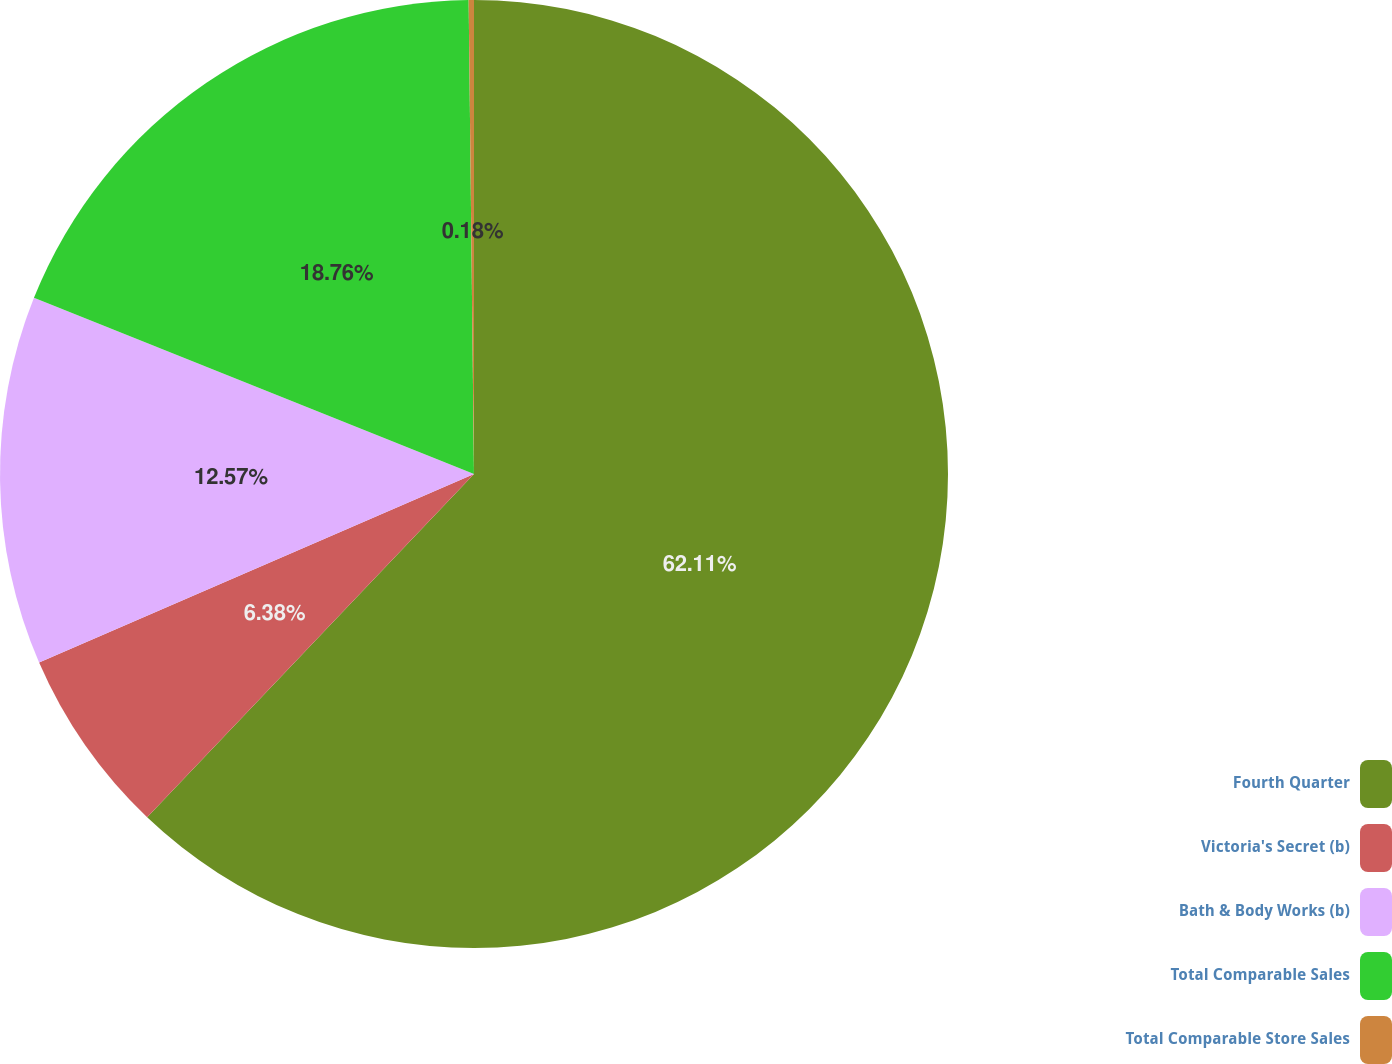Convert chart to OTSL. <chart><loc_0><loc_0><loc_500><loc_500><pie_chart><fcel>Fourth Quarter<fcel>Victoria's Secret (b)<fcel>Bath & Body Works (b)<fcel>Total Comparable Sales<fcel>Total Comparable Store Sales<nl><fcel>62.11%<fcel>6.38%<fcel>12.57%<fcel>18.76%<fcel>0.18%<nl></chart> 